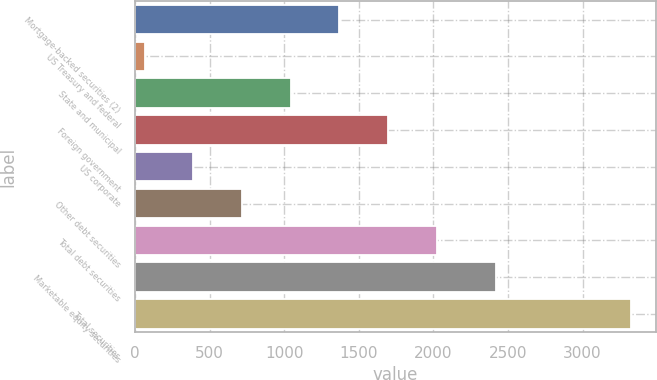Convert chart. <chart><loc_0><loc_0><loc_500><loc_500><bar_chart><fcel>Mortgage-backed securities (2)<fcel>US Treasury and federal<fcel>State and municipal<fcel>Foreign government<fcel>US corporate<fcel>Other debt securities<fcel>Total debt securities<fcel>Marketable equity securities<fcel>Total securities<nl><fcel>1370.4<fcel>66<fcel>1044.3<fcel>1696.5<fcel>392.1<fcel>718.2<fcel>2022.6<fcel>2420<fcel>3327<nl></chart> 